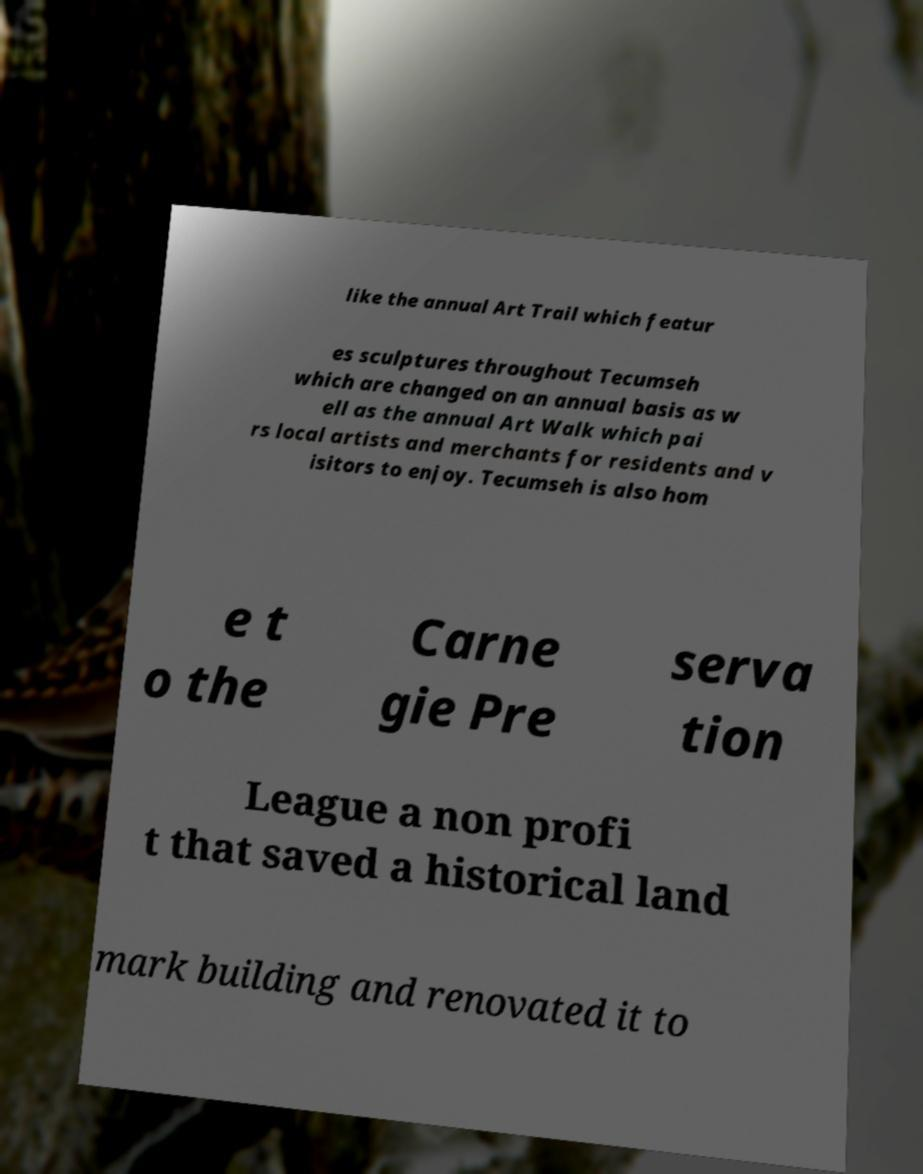Please identify and transcribe the text found in this image. like the annual Art Trail which featur es sculptures throughout Tecumseh which are changed on an annual basis as w ell as the annual Art Walk which pai rs local artists and merchants for residents and v isitors to enjoy. Tecumseh is also hom e t o the Carne gie Pre serva tion League a non profi t that saved a historical land mark building and renovated it to 